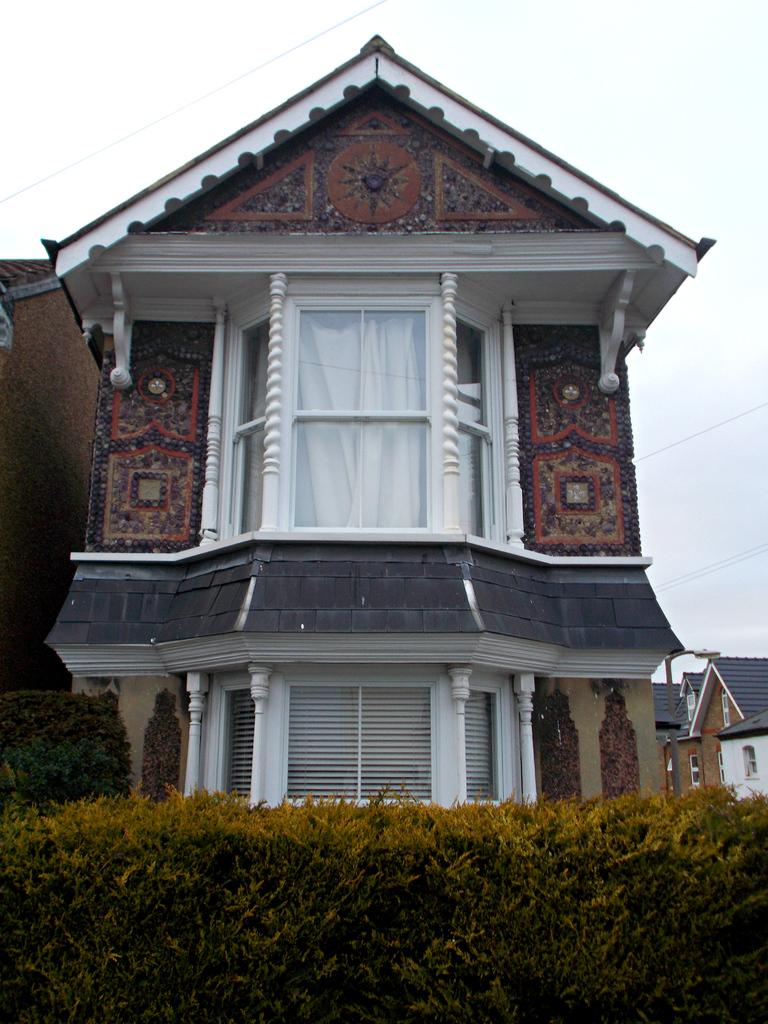What type of structures can be seen in the image? There are houses with roofs and windows in the image. What other elements are present in the image besides the houses? There is a group of plants and wires visible in the image. What is the condition of the sky in the image? The sky is visible in the image and appears cloudy. Can you tell me how many crayons are being used by the woman in the image? There is no woman or crayons present in the image. What type of cork is visible in the image? There is no cork present in the image. 